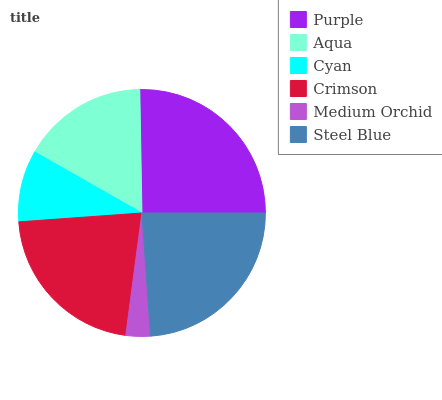Is Medium Orchid the minimum?
Answer yes or no. Yes. Is Purple the maximum?
Answer yes or no. Yes. Is Aqua the minimum?
Answer yes or no. No. Is Aqua the maximum?
Answer yes or no. No. Is Purple greater than Aqua?
Answer yes or no. Yes. Is Aqua less than Purple?
Answer yes or no. Yes. Is Aqua greater than Purple?
Answer yes or no. No. Is Purple less than Aqua?
Answer yes or no. No. Is Crimson the high median?
Answer yes or no. Yes. Is Aqua the low median?
Answer yes or no. Yes. Is Steel Blue the high median?
Answer yes or no. No. Is Steel Blue the low median?
Answer yes or no. No. 